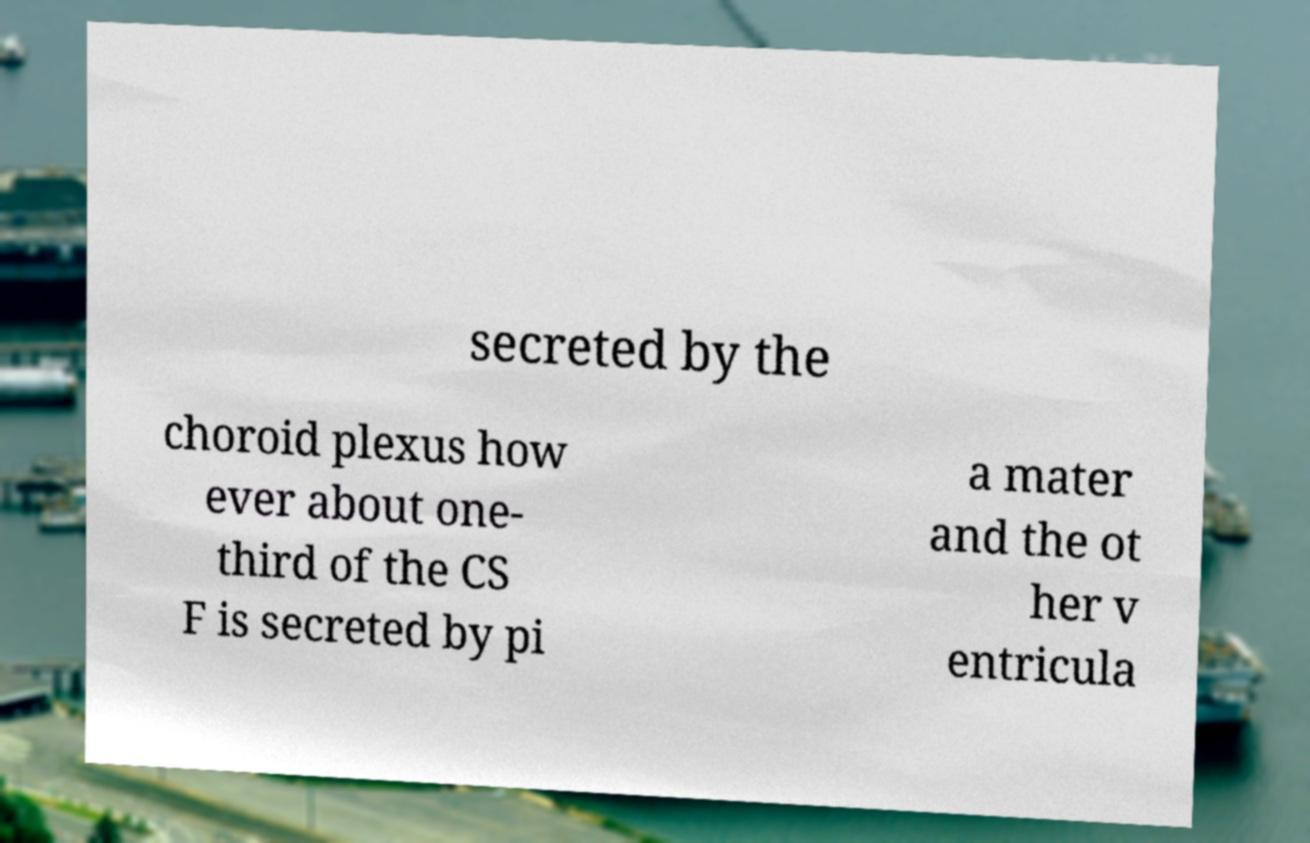Could you extract and type out the text from this image? secreted by the choroid plexus how ever about one- third of the CS F is secreted by pi a mater and the ot her v entricula 